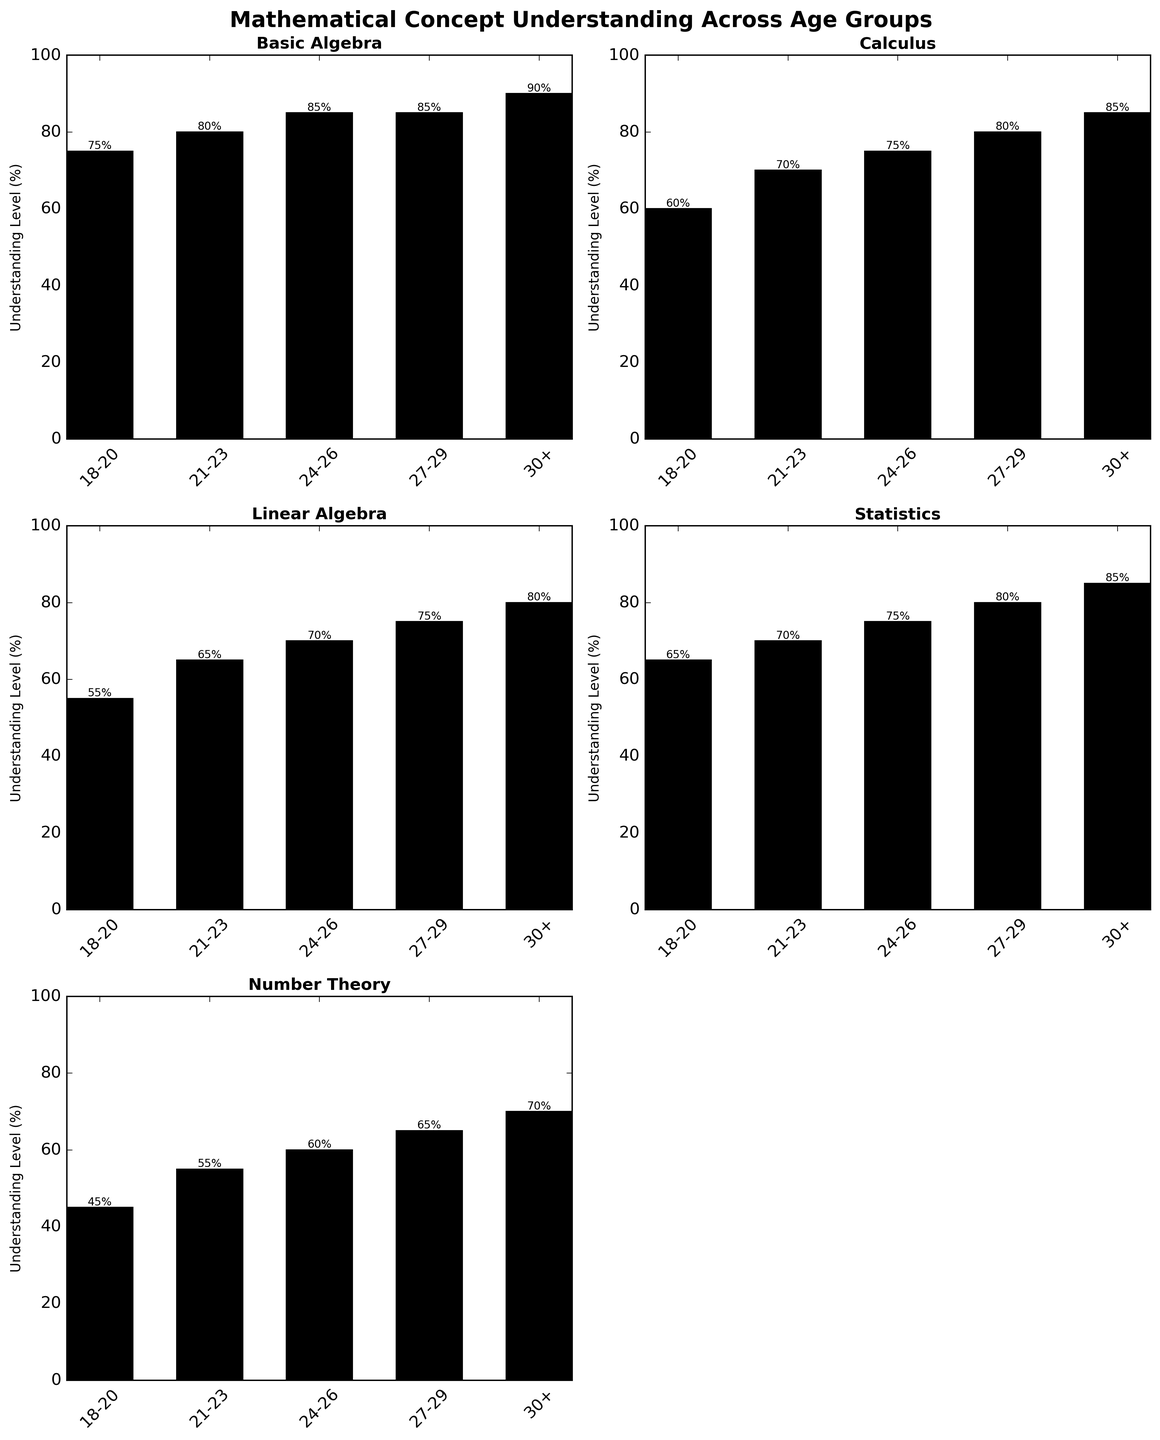What's the average understanding level in Calculus for all age groups? To find the average, sum all the understanding percentages for Calculus (60 + 70 + 75 + 80 + 85) and divide by the number of age groups (5). The calculation is (60 + 70 + 75 + 80 + 85)/5 = 370/5 = 74
Answer: 74 Which age group has the highest understanding level in Basic Algebra? By looking at the heights of the bars in the Basic Algebra subplot, the age group 30+ has the highest bar at 90%
Answer: 30+ Is the understanding level of Linear Algebra for the age group 18-20 higher or lower than the understanding level of Statistics for the age group 30+? The understanding level of Linear Algebra for 18-20 is 55%, and for Statistics at 30+ it’s 85%. 55% is less than 85%, so it is lower
Answer: Lower Which mathematical concept shows the most consistent growth in understanding levels across all age groups? Calculating the differences for each age group (excluding the last empty cell): Basic Algebra (75 to 90), Calculus (60 to 85), Linear Algebra (55 to 80), Statistics (65 to 85), Number Theory (45 to 70). The least variable difference appears in Number Theory, growing by 25% uniformly
Answer: Number Theory What is the difference in the understanding level of Statistics between the age groups 21-23 and 27-29? For Statistics: 27-29 is 80% and 21-23 is 70%. The difference is 80% - 70% = 10%
Answer: 10 Which two age groups have the closest understanding levels in Number Theory? The understanding levels in Number Theory are 45, 55, 60, 65, 70. The smallest difference is between 21-23 and 24-26 (55 and 60) for a 5 point difference
Answer: 21-23 and 24-26 What is the total understanding percentage of Statistics for all age groups? Summing up all understanding percentages for Statistics (65 + 70 + 75 + 80 + 85) gives 375
Answer: 375 